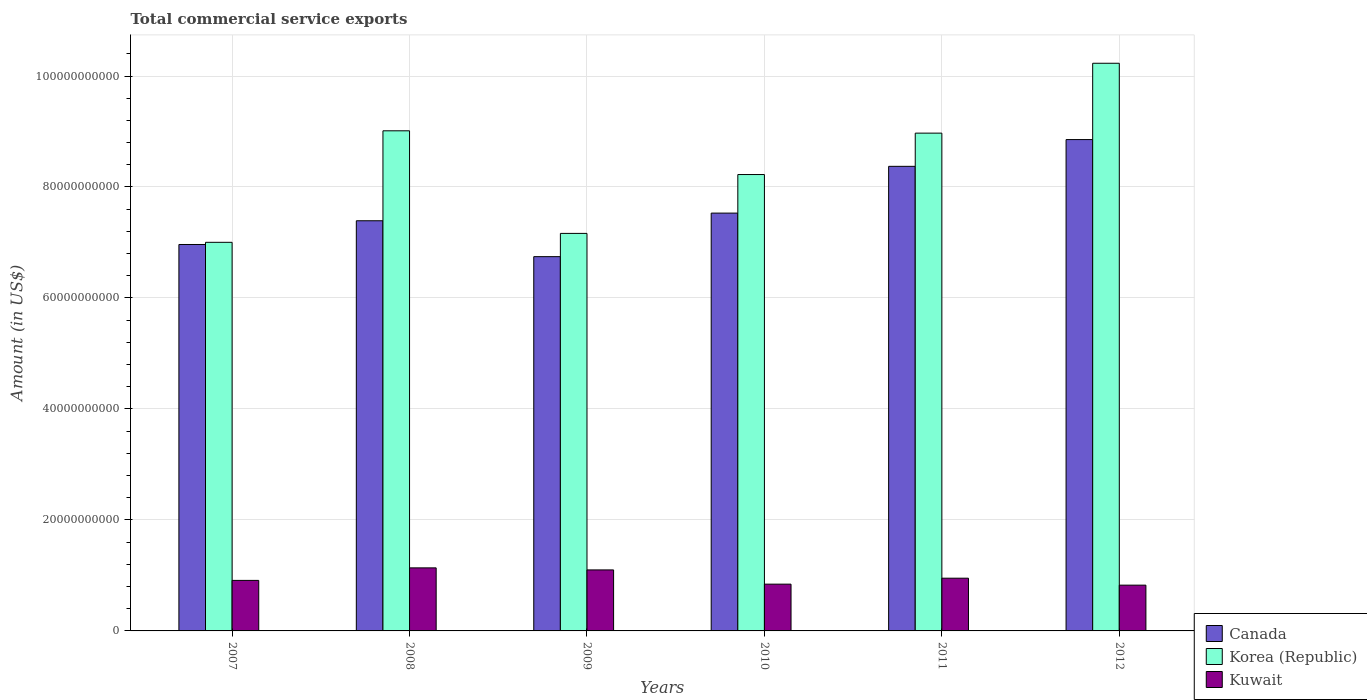How many groups of bars are there?
Make the answer very short. 6. Are the number of bars on each tick of the X-axis equal?
Your answer should be compact. Yes. How many bars are there on the 5th tick from the right?
Keep it short and to the point. 3. In how many cases, is the number of bars for a given year not equal to the number of legend labels?
Offer a very short reply. 0. What is the total commercial service exports in Korea (Republic) in 2010?
Your response must be concise. 8.22e+1. Across all years, what is the maximum total commercial service exports in Kuwait?
Offer a very short reply. 1.14e+1. Across all years, what is the minimum total commercial service exports in Canada?
Your answer should be very brief. 6.74e+1. What is the total total commercial service exports in Korea (Republic) in the graph?
Provide a succinct answer. 5.06e+11. What is the difference between the total commercial service exports in Canada in 2007 and that in 2010?
Ensure brevity in your answer.  -5.66e+09. What is the difference between the total commercial service exports in Canada in 2008 and the total commercial service exports in Korea (Republic) in 2011?
Offer a terse response. -1.58e+1. What is the average total commercial service exports in Korea (Republic) per year?
Make the answer very short. 8.43e+1. In the year 2008, what is the difference between the total commercial service exports in Kuwait and total commercial service exports in Korea (Republic)?
Ensure brevity in your answer.  -7.88e+1. What is the ratio of the total commercial service exports in Kuwait in 2008 to that in 2010?
Provide a short and direct response. 1.35. What is the difference between the highest and the second highest total commercial service exports in Canada?
Make the answer very short. 4.82e+09. What is the difference between the highest and the lowest total commercial service exports in Canada?
Your answer should be compact. 2.11e+1. In how many years, is the total commercial service exports in Korea (Republic) greater than the average total commercial service exports in Korea (Republic) taken over all years?
Provide a succinct answer. 3. What does the 3rd bar from the left in 2012 represents?
Your answer should be very brief. Kuwait. What does the 3rd bar from the right in 2008 represents?
Your response must be concise. Canada. Is it the case that in every year, the sum of the total commercial service exports in Korea (Republic) and total commercial service exports in Canada is greater than the total commercial service exports in Kuwait?
Ensure brevity in your answer.  Yes. How many bars are there?
Ensure brevity in your answer.  18. How many years are there in the graph?
Your answer should be very brief. 6. How are the legend labels stacked?
Offer a terse response. Vertical. What is the title of the graph?
Make the answer very short. Total commercial service exports. What is the label or title of the Y-axis?
Provide a short and direct response. Amount (in US$). What is the Amount (in US$) of Canada in 2007?
Give a very brief answer. 6.96e+1. What is the Amount (in US$) of Korea (Republic) in 2007?
Offer a very short reply. 7.00e+1. What is the Amount (in US$) of Kuwait in 2007?
Offer a terse response. 9.10e+09. What is the Amount (in US$) in Canada in 2008?
Your answer should be compact. 7.39e+1. What is the Amount (in US$) in Korea (Republic) in 2008?
Give a very brief answer. 9.01e+1. What is the Amount (in US$) in Kuwait in 2008?
Provide a succinct answer. 1.14e+1. What is the Amount (in US$) in Canada in 2009?
Provide a short and direct response. 6.74e+1. What is the Amount (in US$) in Korea (Republic) in 2009?
Provide a short and direct response. 7.16e+1. What is the Amount (in US$) of Kuwait in 2009?
Your answer should be compact. 1.10e+1. What is the Amount (in US$) in Canada in 2010?
Offer a terse response. 7.53e+1. What is the Amount (in US$) of Korea (Republic) in 2010?
Make the answer very short. 8.22e+1. What is the Amount (in US$) in Kuwait in 2010?
Your response must be concise. 8.43e+09. What is the Amount (in US$) of Canada in 2011?
Offer a terse response. 8.37e+1. What is the Amount (in US$) of Korea (Republic) in 2011?
Offer a very short reply. 8.97e+1. What is the Amount (in US$) of Kuwait in 2011?
Provide a short and direct response. 9.50e+09. What is the Amount (in US$) of Canada in 2012?
Provide a short and direct response. 8.85e+1. What is the Amount (in US$) in Korea (Republic) in 2012?
Provide a succinct answer. 1.02e+11. What is the Amount (in US$) in Kuwait in 2012?
Give a very brief answer. 8.25e+09. Across all years, what is the maximum Amount (in US$) of Canada?
Offer a terse response. 8.85e+1. Across all years, what is the maximum Amount (in US$) of Korea (Republic)?
Your response must be concise. 1.02e+11. Across all years, what is the maximum Amount (in US$) in Kuwait?
Give a very brief answer. 1.14e+1. Across all years, what is the minimum Amount (in US$) of Canada?
Provide a short and direct response. 6.74e+1. Across all years, what is the minimum Amount (in US$) of Korea (Republic)?
Provide a short and direct response. 7.00e+1. Across all years, what is the minimum Amount (in US$) of Kuwait?
Your answer should be very brief. 8.25e+09. What is the total Amount (in US$) of Canada in the graph?
Give a very brief answer. 4.59e+11. What is the total Amount (in US$) of Korea (Republic) in the graph?
Your response must be concise. 5.06e+11. What is the total Amount (in US$) in Kuwait in the graph?
Your response must be concise. 5.76e+1. What is the difference between the Amount (in US$) of Canada in 2007 and that in 2008?
Offer a very short reply. -4.28e+09. What is the difference between the Amount (in US$) of Korea (Republic) in 2007 and that in 2008?
Provide a succinct answer. -2.01e+1. What is the difference between the Amount (in US$) of Kuwait in 2007 and that in 2008?
Keep it short and to the point. -2.26e+09. What is the difference between the Amount (in US$) in Canada in 2007 and that in 2009?
Keep it short and to the point. 2.19e+09. What is the difference between the Amount (in US$) of Korea (Republic) in 2007 and that in 2009?
Make the answer very short. -1.61e+09. What is the difference between the Amount (in US$) in Kuwait in 2007 and that in 2009?
Give a very brief answer. -1.89e+09. What is the difference between the Amount (in US$) in Canada in 2007 and that in 2010?
Ensure brevity in your answer.  -5.66e+09. What is the difference between the Amount (in US$) in Korea (Republic) in 2007 and that in 2010?
Make the answer very short. -1.22e+1. What is the difference between the Amount (in US$) of Kuwait in 2007 and that in 2010?
Offer a terse response. 6.75e+08. What is the difference between the Amount (in US$) in Canada in 2007 and that in 2011?
Your answer should be compact. -1.41e+1. What is the difference between the Amount (in US$) of Korea (Republic) in 2007 and that in 2011?
Ensure brevity in your answer.  -1.97e+1. What is the difference between the Amount (in US$) in Kuwait in 2007 and that in 2011?
Make the answer very short. -3.98e+08. What is the difference between the Amount (in US$) in Canada in 2007 and that in 2012?
Provide a short and direct response. -1.89e+1. What is the difference between the Amount (in US$) in Korea (Republic) in 2007 and that in 2012?
Ensure brevity in your answer.  -3.23e+1. What is the difference between the Amount (in US$) of Kuwait in 2007 and that in 2012?
Provide a succinct answer. 8.54e+08. What is the difference between the Amount (in US$) in Canada in 2008 and that in 2009?
Give a very brief answer. 6.47e+09. What is the difference between the Amount (in US$) in Korea (Republic) in 2008 and that in 2009?
Offer a very short reply. 1.85e+1. What is the difference between the Amount (in US$) of Kuwait in 2008 and that in 2009?
Your answer should be compact. 3.67e+08. What is the difference between the Amount (in US$) of Canada in 2008 and that in 2010?
Your response must be concise. -1.38e+09. What is the difference between the Amount (in US$) in Korea (Republic) in 2008 and that in 2010?
Keep it short and to the point. 7.88e+09. What is the difference between the Amount (in US$) of Kuwait in 2008 and that in 2010?
Keep it short and to the point. 2.93e+09. What is the difference between the Amount (in US$) of Canada in 2008 and that in 2011?
Provide a short and direct response. -9.81e+09. What is the difference between the Amount (in US$) in Korea (Republic) in 2008 and that in 2011?
Keep it short and to the point. 4.21e+08. What is the difference between the Amount (in US$) in Kuwait in 2008 and that in 2011?
Give a very brief answer. 1.86e+09. What is the difference between the Amount (in US$) of Canada in 2008 and that in 2012?
Keep it short and to the point. -1.46e+1. What is the difference between the Amount (in US$) of Korea (Republic) in 2008 and that in 2012?
Provide a short and direct response. -1.22e+1. What is the difference between the Amount (in US$) in Kuwait in 2008 and that in 2012?
Ensure brevity in your answer.  3.11e+09. What is the difference between the Amount (in US$) in Canada in 2009 and that in 2010?
Offer a terse response. -7.85e+09. What is the difference between the Amount (in US$) of Korea (Republic) in 2009 and that in 2010?
Give a very brief answer. -1.06e+1. What is the difference between the Amount (in US$) of Kuwait in 2009 and that in 2010?
Ensure brevity in your answer.  2.57e+09. What is the difference between the Amount (in US$) of Canada in 2009 and that in 2011?
Offer a terse response. -1.63e+1. What is the difference between the Amount (in US$) of Korea (Republic) in 2009 and that in 2011?
Keep it short and to the point. -1.81e+1. What is the difference between the Amount (in US$) in Kuwait in 2009 and that in 2011?
Provide a short and direct response. 1.49e+09. What is the difference between the Amount (in US$) of Canada in 2009 and that in 2012?
Keep it short and to the point. -2.11e+1. What is the difference between the Amount (in US$) in Korea (Republic) in 2009 and that in 2012?
Your answer should be very brief. -3.07e+1. What is the difference between the Amount (in US$) of Kuwait in 2009 and that in 2012?
Your response must be concise. 2.75e+09. What is the difference between the Amount (in US$) of Canada in 2010 and that in 2011?
Ensure brevity in your answer.  -8.43e+09. What is the difference between the Amount (in US$) in Korea (Republic) in 2010 and that in 2011?
Make the answer very short. -7.46e+09. What is the difference between the Amount (in US$) of Kuwait in 2010 and that in 2011?
Give a very brief answer. -1.07e+09. What is the difference between the Amount (in US$) of Canada in 2010 and that in 2012?
Offer a very short reply. -1.32e+1. What is the difference between the Amount (in US$) in Korea (Republic) in 2010 and that in 2012?
Provide a short and direct response. -2.01e+1. What is the difference between the Amount (in US$) of Kuwait in 2010 and that in 2012?
Provide a short and direct response. 1.79e+08. What is the difference between the Amount (in US$) of Canada in 2011 and that in 2012?
Give a very brief answer. -4.82e+09. What is the difference between the Amount (in US$) of Korea (Republic) in 2011 and that in 2012?
Your answer should be very brief. -1.26e+1. What is the difference between the Amount (in US$) in Kuwait in 2011 and that in 2012?
Provide a short and direct response. 1.25e+09. What is the difference between the Amount (in US$) of Canada in 2007 and the Amount (in US$) of Korea (Republic) in 2008?
Provide a short and direct response. -2.05e+1. What is the difference between the Amount (in US$) of Canada in 2007 and the Amount (in US$) of Kuwait in 2008?
Your answer should be compact. 5.83e+1. What is the difference between the Amount (in US$) in Korea (Republic) in 2007 and the Amount (in US$) in Kuwait in 2008?
Your answer should be very brief. 5.87e+1. What is the difference between the Amount (in US$) of Canada in 2007 and the Amount (in US$) of Korea (Republic) in 2009?
Give a very brief answer. -2.00e+09. What is the difference between the Amount (in US$) in Canada in 2007 and the Amount (in US$) in Kuwait in 2009?
Offer a terse response. 5.86e+1. What is the difference between the Amount (in US$) in Korea (Republic) in 2007 and the Amount (in US$) in Kuwait in 2009?
Offer a very short reply. 5.90e+1. What is the difference between the Amount (in US$) of Canada in 2007 and the Amount (in US$) of Korea (Republic) in 2010?
Keep it short and to the point. -1.26e+1. What is the difference between the Amount (in US$) in Canada in 2007 and the Amount (in US$) in Kuwait in 2010?
Ensure brevity in your answer.  6.12e+1. What is the difference between the Amount (in US$) in Korea (Republic) in 2007 and the Amount (in US$) in Kuwait in 2010?
Provide a succinct answer. 6.16e+1. What is the difference between the Amount (in US$) in Canada in 2007 and the Amount (in US$) in Korea (Republic) in 2011?
Provide a short and direct response. -2.01e+1. What is the difference between the Amount (in US$) of Canada in 2007 and the Amount (in US$) of Kuwait in 2011?
Provide a succinct answer. 6.01e+1. What is the difference between the Amount (in US$) in Korea (Republic) in 2007 and the Amount (in US$) in Kuwait in 2011?
Give a very brief answer. 6.05e+1. What is the difference between the Amount (in US$) of Canada in 2007 and the Amount (in US$) of Korea (Republic) in 2012?
Offer a terse response. -3.27e+1. What is the difference between the Amount (in US$) in Canada in 2007 and the Amount (in US$) in Kuwait in 2012?
Offer a terse response. 6.14e+1. What is the difference between the Amount (in US$) of Korea (Republic) in 2007 and the Amount (in US$) of Kuwait in 2012?
Keep it short and to the point. 6.18e+1. What is the difference between the Amount (in US$) in Canada in 2008 and the Amount (in US$) in Korea (Republic) in 2009?
Ensure brevity in your answer.  2.28e+09. What is the difference between the Amount (in US$) in Canada in 2008 and the Amount (in US$) in Kuwait in 2009?
Your answer should be compact. 6.29e+1. What is the difference between the Amount (in US$) in Korea (Republic) in 2008 and the Amount (in US$) in Kuwait in 2009?
Provide a short and direct response. 7.91e+1. What is the difference between the Amount (in US$) in Canada in 2008 and the Amount (in US$) in Korea (Republic) in 2010?
Your answer should be compact. -8.33e+09. What is the difference between the Amount (in US$) in Canada in 2008 and the Amount (in US$) in Kuwait in 2010?
Your answer should be compact. 6.55e+1. What is the difference between the Amount (in US$) of Korea (Republic) in 2008 and the Amount (in US$) of Kuwait in 2010?
Keep it short and to the point. 8.17e+1. What is the difference between the Amount (in US$) in Canada in 2008 and the Amount (in US$) in Korea (Republic) in 2011?
Provide a short and direct response. -1.58e+1. What is the difference between the Amount (in US$) of Canada in 2008 and the Amount (in US$) of Kuwait in 2011?
Provide a short and direct response. 6.44e+1. What is the difference between the Amount (in US$) in Korea (Republic) in 2008 and the Amount (in US$) in Kuwait in 2011?
Ensure brevity in your answer.  8.06e+1. What is the difference between the Amount (in US$) of Canada in 2008 and the Amount (in US$) of Korea (Republic) in 2012?
Offer a very short reply. -2.84e+1. What is the difference between the Amount (in US$) of Canada in 2008 and the Amount (in US$) of Kuwait in 2012?
Offer a terse response. 6.57e+1. What is the difference between the Amount (in US$) in Korea (Republic) in 2008 and the Amount (in US$) in Kuwait in 2012?
Make the answer very short. 8.19e+1. What is the difference between the Amount (in US$) of Canada in 2009 and the Amount (in US$) of Korea (Republic) in 2010?
Your answer should be very brief. -1.48e+1. What is the difference between the Amount (in US$) of Canada in 2009 and the Amount (in US$) of Kuwait in 2010?
Your response must be concise. 5.90e+1. What is the difference between the Amount (in US$) in Korea (Republic) in 2009 and the Amount (in US$) in Kuwait in 2010?
Your response must be concise. 6.32e+1. What is the difference between the Amount (in US$) of Canada in 2009 and the Amount (in US$) of Korea (Republic) in 2011?
Offer a terse response. -2.23e+1. What is the difference between the Amount (in US$) of Canada in 2009 and the Amount (in US$) of Kuwait in 2011?
Your answer should be compact. 5.79e+1. What is the difference between the Amount (in US$) of Korea (Republic) in 2009 and the Amount (in US$) of Kuwait in 2011?
Your answer should be compact. 6.21e+1. What is the difference between the Amount (in US$) in Canada in 2009 and the Amount (in US$) in Korea (Republic) in 2012?
Offer a terse response. -3.49e+1. What is the difference between the Amount (in US$) of Canada in 2009 and the Amount (in US$) of Kuwait in 2012?
Your response must be concise. 5.92e+1. What is the difference between the Amount (in US$) in Korea (Republic) in 2009 and the Amount (in US$) in Kuwait in 2012?
Provide a short and direct response. 6.34e+1. What is the difference between the Amount (in US$) of Canada in 2010 and the Amount (in US$) of Korea (Republic) in 2011?
Make the answer very short. -1.44e+1. What is the difference between the Amount (in US$) of Canada in 2010 and the Amount (in US$) of Kuwait in 2011?
Offer a very short reply. 6.58e+1. What is the difference between the Amount (in US$) of Korea (Republic) in 2010 and the Amount (in US$) of Kuwait in 2011?
Ensure brevity in your answer.  7.27e+1. What is the difference between the Amount (in US$) in Canada in 2010 and the Amount (in US$) in Korea (Republic) in 2012?
Your response must be concise. -2.70e+1. What is the difference between the Amount (in US$) in Canada in 2010 and the Amount (in US$) in Kuwait in 2012?
Give a very brief answer. 6.70e+1. What is the difference between the Amount (in US$) of Korea (Republic) in 2010 and the Amount (in US$) of Kuwait in 2012?
Your answer should be very brief. 7.40e+1. What is the difference between the Amount (in US$) of Canada in 2011 and the Amount (in US$) of Korea (Republic) in 2012?
Provide a short and direct response. -1.86e+1. What is the difference between the Amount (in US$) in Canada in 2011 and the Amount (in US$) in Kuwait in 2012?
Your response must be concise. 7.55e+1. What is the difference between the Amount (in US$) in Korea (Republic) in 2011 and the Amount (in US$) in Kuwait in 2012?
Your answer should be very brief. 8.15e+1. What is the average Amount (in US$) in Canada per year?
Provide a short and direct response. 7.64e+1. What is the average Amount (in US$) in Korea (Republic) per year?
Offer a very short reply. 8.43e+1. What is the average Amount (in US$) of Kuwait per year?
Offer a terse response. 9.61e+09. In the year 2007, what is the difference between the Amount (in US$) of Canada and Amount (in US$) of Korea (Republic)?
Ensure brevity in your answer.  -3.92e+08. In the year 2007, what is the difference between the Amount (in US$) of Canada and Amount (in US$) of Kuwait?
Provide a succinct answer. 6.05e+1. In the year 2007, what is the difference between the Amount (in US$) of Korea (Republic) and Amount (in US$) of Kuwait?
Your answer should be compact. 6.09e+1. In the year 2008, what is the difference between the Amount (in US$) of Canada and Amount (in US$) of Korea (Republic)?
Offer a very short reply. -1.62e+1. In the year 2008, what is the difference between the Amount (in US$) in Canada and Amount (in US$) in Kuwait?
Offer a terse response. 6.26e+1. In the year 2008, what is the difference between the Amount (in US$) in Korea (Republic) and Amount (in US$) in Kuwait?
Provide a short and direct response. 7.88e+1. In the year 2009, what is the difference between the Amount (in US$) of Canada and Amount (in US$) of Korea (Republic)?
Your answer should be compact. -4.19e+09. In the year 2009, what is the difference between the Amount (in US$) of Canada and Amount (in US$) of Kuwait?
Offer a terse response. 5.65e+1. In the year 2009, what is the difference between the Amount (in US$) of Korea (Republic) and Amount (in US$) of Kuwait?
Keep it short and to the point. 6.06e+1. In the year 2010, what is the difference between the Amount (in US$) of Canada and Amount (in US$) of Korea (Republic)?
Provide a short and direct response. -6.95e+09. In the year 2010, what is the difference between the Amount (in US$) in Canada and Amount (in US$) in Kuwait?
Your answer should be very brief. 6.69e+1. In the year 2010, what is the difference between the Amount (in US$) in Korea (Republic) and Amount (in US$) in Kuwait?
Offer a very short reply. 7.38e+1. In the year 2011, what is the difference between the Amount (in US$) of Canada and Amount (in US$) of Korea (Republic)?
Your answer should be compact. -5.98e+09. In the year 2011, what is the difference between the Amount (in US$) of Canada and Amount (in US$) of Kuwait?
Make the answer very short. 7.42e+1. In the year 2011, what is the difference between the Amount (in US$) of Korea (Republic) and Amount (in US$) of Kuwait?
Provide a short and direct response. 8.02e+1. In the year 2012, what is the difference between the Amount (in US$) in Canada and Amount (in US$) in Korea (Republic)?
Your answer should be compact. -1.38e+1. In the year 2012, what is the difference between the Amount (in US$) in Canada and Amount (in US$) in Kuwait?
Offer a very short reply. 8.03e+1. In the year 2012, what is the difference between the Amount (in US$) in Korea (Republic) and Amount (in US$) in Kuwait?
Keep it short and to the point. 9.40e+1. What is the ratio of the Amount (in US$) of Canada in 2007 to that in 2008?
Offer a very short reply. 0.94. What is the ratio of the Amount (in US$) of Korea (Republic) in 2007 to that in 2008?
Offer a very short reply. 0.78. What is the ratio of the Amount (in US$) in Kuwait in 2007 to that in 2008?
Your answer should be compact. 0.8. What is the ratio of the Amount (in US$) in Canada in 2007 to that in 2009?
Provide a short and direct response. 1.03. What is the ratio of the Amount (in US$) in Korea (Republic) in 2007 to that in 2009?
Your answer should be compact. 0.98. What is the ratio of the Amount (in US$) in Kuwait in 2007 to that in 2009?
Make the answer very short. 0.83. What is the ratio of the Amount (in US$) in Canada in 2007 to that in 2010?
Provide a short and direct response. 0.92. What is the ratio of the Amount (in US$) of Korea (Republic) in 2007 to that in 2010?
Offer a terse response. 0.85. What is the ratio of the Amount (in US$) in Kuwait in 2007 to that in 2010?
Offer a very short reply. 1.08. What is the ratio of the Amount (in US$) in Canada in 2007 to that in 2011?
Keep it short and to the point. 0.83. What is the ratio of the Amount (in US$) of Korea (Republic) in 2007 to that in 2011?
Offer a terse response. 0.78. What is the ratio of the Amount (in US$) of Kuwait in 2007 to that in 2011?
Provide a short and direct response. 0.96. What is the ratio of the Amount (in US$) in Canada in 2007 to that in 2012?
Keep it short and to the point. 0.79. What is the ratio of the Amount (in US$) of Korea (Republic) in 2007 to that in 2012?
Keep it short and to the point. 0.68. What is the ratio of the Amount (in US$) in Kuwait in 2007 to that in 2012?
Provide a short and direct response. 1.1. What is the ratio of the Amount (in US$) of Canada in 2008 to that in 2009?
Make the answer very short. 1.1. What is the ratio of the Amount (in US$) of Korea (Republic) in 2008 to that in 2009?
Your answer should be compact. 1.26. What is the ratio of the Amount (in US$) of Kuwait in 2008 to that in 2009?
Your answer should be very brief. 1.03. What is the ratio of the Amount (in US$) of Canada in 2008 to that in 2010?
Make the answer very short. 0.98. What is the ratio of the Amount (in US$) of Korea (Republic) in 2008 to that in 2010?
Ensure brevity in your answer.  1.1. What is the ratio of the Amount (in US$) of Kuwait in 2008 to that in 2010?
Your answer should be compact. 1.35. What is the ratio of the Amount (in US$) in Canada in 2008 to that in 2011?
Make the answer very short. 0.88. What is the ratio of the Amount (in US$) in Kuwait in 2008 to that in 2011?
Make the answer very short. 1.2. What is the ratio of the Amount (in US$) of Canada in 2008 to that in 2012?
Offer a terse response. 0.83. What is the ratio of the Amount (in US$) in Korea (Republic) in 2008 to that in 2012?
Make the answer very short. 0.88. What is the ratio of the Amount (in US$) of Kuwait in 2008 to that in 2012?
Your answer should be very brief. 1.38. What is the ratio of the Amount (in US$) of Canada in 2009 to that in 2010?
Provide a short and direct response. 0.9. What is the ratio of the Amount (in US$) in Korea (Republic) in 2009 to that in 2010?
Your answer should be compact. 0.87. What is the ratio of the Amount (in US$) in Kuwait in 2009 to that in 2010?
Ensure brevity in your answer.  1.3. What is the ratio of the Amount (in US$) in Canada in 2009 to that in 2011?
Keep it short and to the point. 0.81. What is the ratio of the Amount (in US$) in Korea (Republic) in 2009 to that in 2011?
Make the answer very short. 0.8. What is the ratio of the Amount (in US$) in Kuwait in 2009 to that in 2011?
Offer a very short reply. 1.16. What is the ratio of the Amount (in US$) of Canada in 2009 to that in 2012?
Your answer should be compact. 0.76. What is the ratio of the Amount (in US$) of Korea (Republic) in 2009 to that in 2012?
Offer a terse response. 0.7. What is the ratio of the Amount (in US$) in Kuwait in 2009 to that in 2012?
Ensure brevity in your answer.  1.33. What is the ratio of the Amount (in US$) of Canada in 2010 to that in 2011?
Your response must be concise. 0.9. What is the ratio of the Amount (in US$) of Korea (Republic) in 2010 to that in 2011?
Give a very brief answer. 0.92. What is the ratio of the Amount (in US$) of Kuwait in 2010 to that in 2011?
Provide a short and direct response. 0.89. What is the ratio of the Amount (in US$) of Canada in 2010 to that in 2012?
Your answer should be very brief. 0.85. What is the ratio of the Amount (in US$) of Korea (Republic) in 2010 to that in 2012?
Make the answer very short. 0.8. What is the ratio of the Amount (in US$) in Kuwait in 2010 to that in 2012?
Your response must be concise. 1.02. What is the ratio of the Amount (in US$) in Canada in 2011 to that in 2012?
Provide a succinct answer. 0.95. What is the ratio of the Amount (in US$) of Korea (Republic) in 2011 to that in 2012?
Keep it short and to the point. 0.88. What is the ratio of the Amount (in US$) of Kuwait in 2011 to that in 2012?
Keep it short and to the point. 1.15. What is the difference between the highest and the second highest Amount (in US$) of Canada?
Make the answer very short. 4.82e+09. What is the difference between the highest and the second highest Amount (in US$) in Korea (Republic)?
Offer a very short reply. 1.22e+1. What is the difference between the highest and the second highest Amount (in US$) in Kuwait?
Make the answer very short. 3.67e+08. What is the difference between the highest and the lowest Amount (in US$) in Canada?
Offer a very short reply. 2.11e+1. What is the difference between the highest and the lowest Amount (in US$) of Korea (Republic)?
Keep it short and to the point. 3.23e+1. What is the difference between the highest and the lowest Amount (in US$) in Kuwait?
Keep it short and to the point. 3.11e+09. 